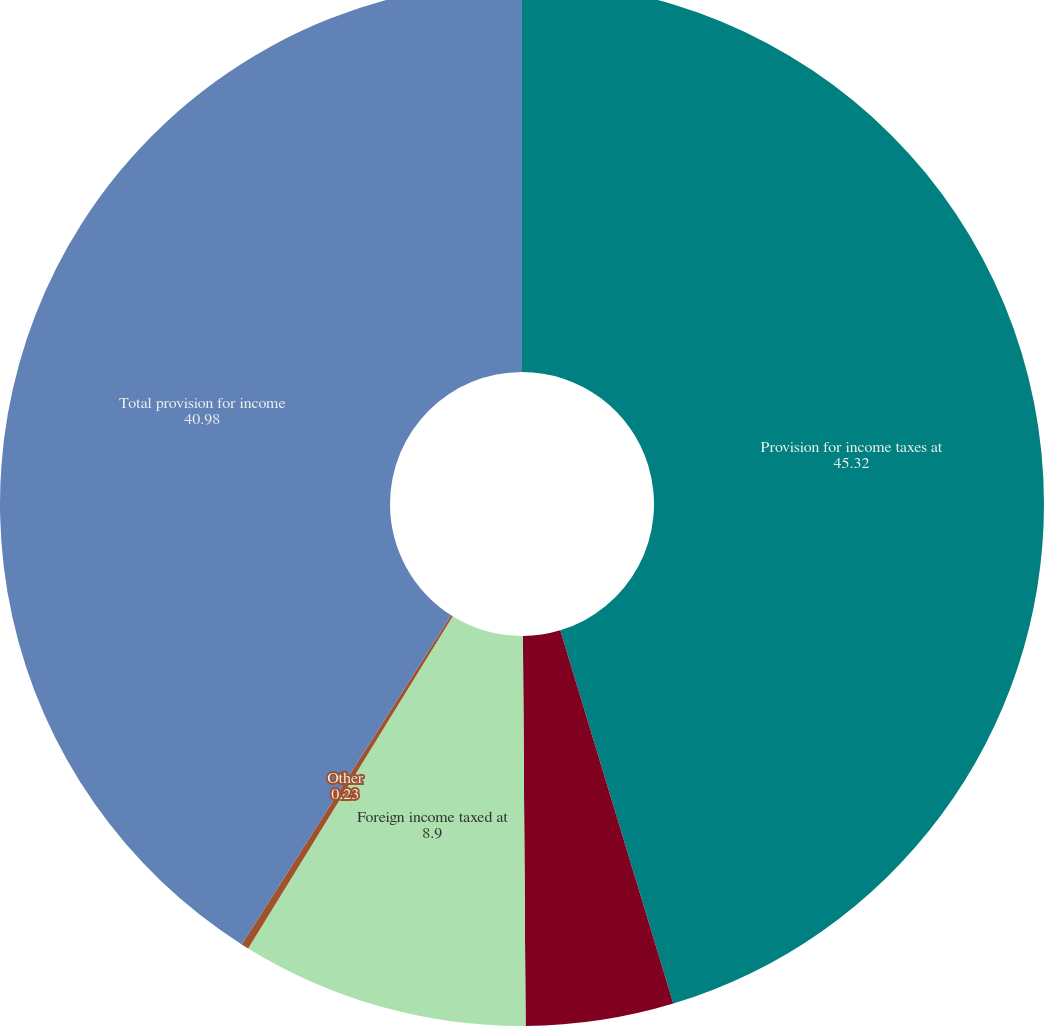Convert chart to OTSL. <chart><loc_0><loc_0><loc_500><loc_500><pie_chart><fcel>Provision for income taxes at<fcel>State and local income taxes<fcel>Foreign income taxed at<fcel>Other<fcel>Total provision for income<nl><fcel>45.32%<fcel>4.57%<fcel>8.9%<fcel>0.23%<fcel>40.98%<nl></chart> 